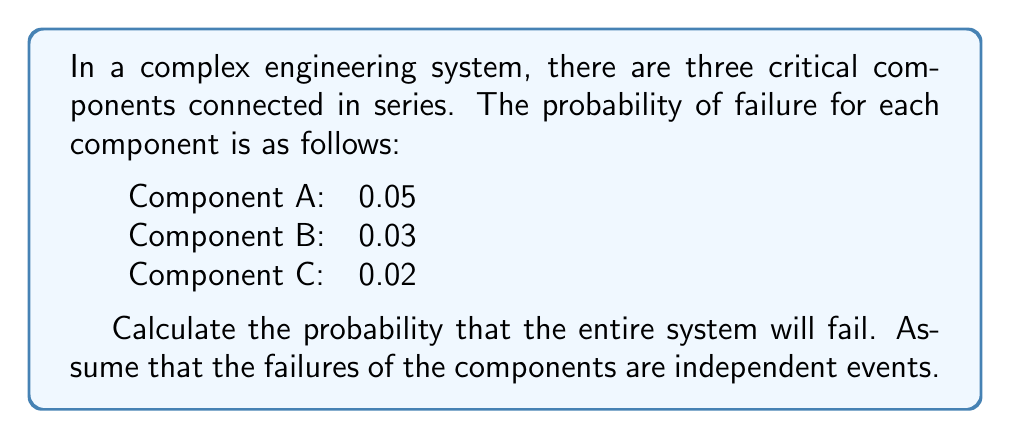Solve this math problem. To solve this problem, we need to follow these steps:

1. Understand the series connection:
   In a series system, if any one component fails, the entire system fails. Therefore, we need to calculate the probability that at least one component fails.

2. Calculate the probability of system success:
   The system succeeds only if all components succeed. We can calculate this as:
   
   $$P(\text{System Success}) = P(A \text{ succeeds}) \times P(B \text{ succeeds}) \times P(C \text{ succeeds})$$

   For each component, the probability of success is 1 minus the probability of failure:

   $$P(\text{System Success}) = (1 - 0.05) \times (1 - 0.03) \times (1 - 0.02)$$
   $$P(\text{System Success}) = 0.95 \times 0.97 \times 0.98$$
   $$P(\text{System Success}) = 0.9023$$

3. Calculate the probability of system failure:
   The probability of system failure is the complement of the probability of system success:

   $$P(\text{System Failure}) = 1 - P(\text{System Success})$$
   $$P(\text{System Failure}) = 1 - 0.9023$$
   $$P(\text{System Failure}) = 0.0977$$

Therefore, the probability that the entire system will fail is approximately 0.0977 or 9.77%.
Answer: $0.0977$ or $9.77\%$ 